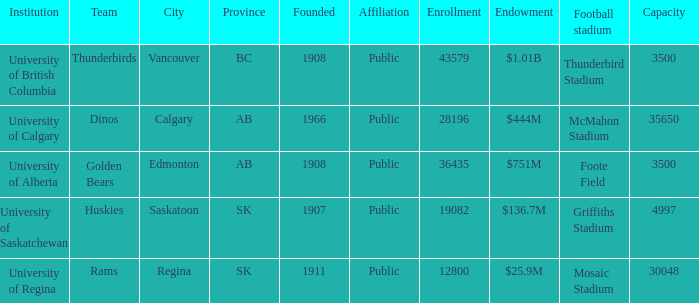What is the capacity for the  institution of university of alberta? 3500.0. 